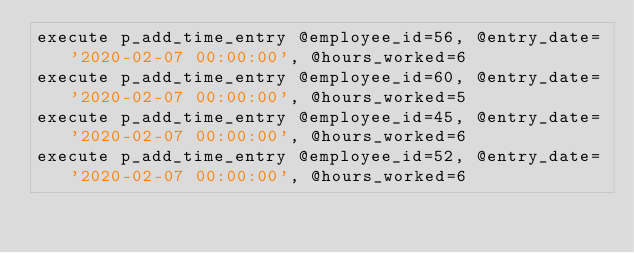Convert code to text. <code><loc_0><loc_0><loc_500><loc_500><_SQL_>execute p_add_time_entry @employee_id=56, @entry_date='2020-02-07 00:00:00', @hours_worked=6
execute p_add_time_entry @employee_id=60, @entry_date='2020-02-07 00:00:00', @hours_worked=5
execute p_add_time_entry @employee_id=45, @entry_date='2020-02-07 00:00:00', @hours_worked=6
execute p_add_time_entry @employee_id=52, @entry_date='2020-02-07 00:00:00', @hours_worked=6

</code> 